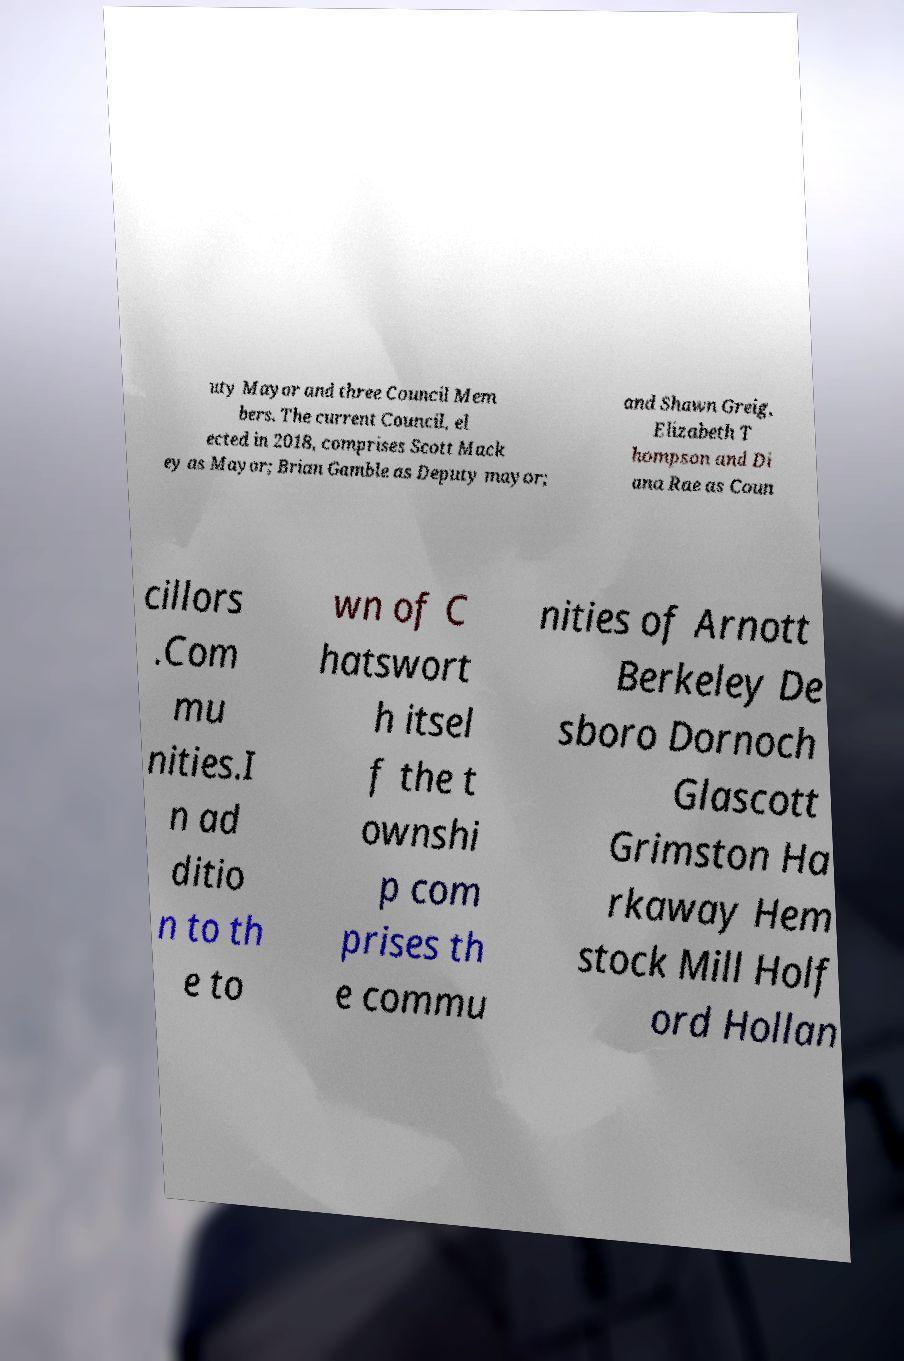There's text embedded in this image that I need extracted. Can you transcribe it verbatim? uty Mayor and three Council Mem bers. The current Council, el ected in 2018, comprises Scott Mack ey as Mayor; Brian Gamble as Deputy mayor; and Shawn Greig, Elizabeth T hompson and Di ana Rae as Coun cillors .Com mu nities.I n ad ditio n to th e to wn of C hatswort h itsel f the t ownshi p com prises th e commu nities of Arnott Berkeley De sboro Dornoch Glascott Grimston Ha rkaway Hem stock Mill Holf ord Hollan 